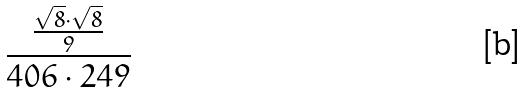<formula> <loc_0><loc_0><loc_500><loc_500>\frac { \frac { \sqrt { 8 } \cdot \sqrt { 8 } } { 9 } } { 4 0 6 \cdot 2 4 9 }</formula> 